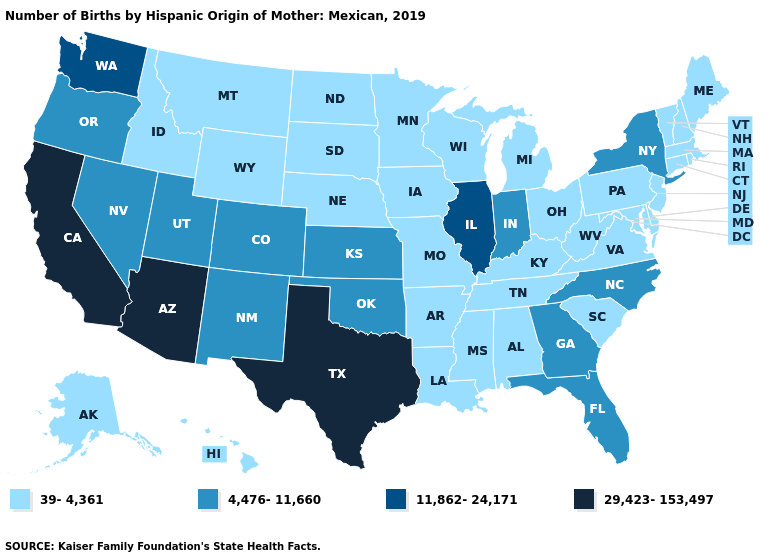What is the value of Rhode Island?
Concise answer only. 39-4,361. What is the highest value in states that border New Jersey?
Keep it brief. 4,476-11,660. Among the states that border North Carolina , does Tennessee have the lowest value?
Answer briefly. Yes. What is the value of Hawaii?
Write a very short answer. 39-4,361. Name the states that have a value in the range 4,476-11,660?
Quick response, please. Colorado, Florida, Georgia, Indiana, Kansas, Nevada, New Mexico, New York, North Carolina, Oklahoma, Oregon, Utah. Does New Jersey have the highest value in the Northeast?
Short answer required. No. Does New Jersey have a lower value than North Dakota?
Be succinct. No. Is the legend a continuous bar?
Quick response, please. No. Which states have the lowest value in the USA?
Quick response, please. Alabama, Alaska, Arkansas, Connecticut, Delaware, Hawaii, Idaho, Iowa, Kentucky, Louisiana, Maine, Maryland, Massachusetts, Michigan, Minnesota, Mississippi, Missouri, Montana, Nebraska, New Hampshire, New Jersey, North Dakota, Ohio, Pennsylvania, Rhode Island, South Carolina, South Dakota, Tennessee, Vermont, Virginia, West Virginia, Wisconsin, Wyoming. Which states hav the highest value in the West?
Short answer required. Arizona, California. Among the states that border Oklahoma , does Texas have the lowest value?
Keep it brief. No. Among the states that border North Carolina , which have the lowest value?
Be succinct. South Carolina, Tennessee, Virginia. What is the value of Arizona?
Concise answer only. 29,423-153,497. Which states have the lowest value in the USA?
Quick response, please. Alabama, Alaska, Arkansas, Connecticut, Delaware, Hawaii, Idaho, Iowa, Kentucky, Louisiana, Maine, Maryland, Massachusetts, Michigan, Minnesota, Mississippi, Missouri, Montana, Nebraska, New Hampshire, New Jersey, North Dakota, Ohio, Pennsylvania, Rhode Island, South Carolina, South Dakota, Tennessee, Vermont, Virginia, West Virginia, Wisconsin, Wyoming. Name the states that have a value in the range 39-4,361?
Keep it brief. Alabama, Alaska, Arkansas, Connecticut, Delaware, Hawaii, Idaho, Iowa, Kentucky, Louisiana, Maine, Maryland, Massachusetts, Michigan, Minnesota, Mississippi, Missouri, Montana, Nebraska, New Hampshire, New Jersey, North Dakota, Ohio, Pennsylvania, Rhode Island, South Carolina, South Dakota, Tennessee, Vermont, Virginia, West Virginia, Wisconsin, Wyoming. 